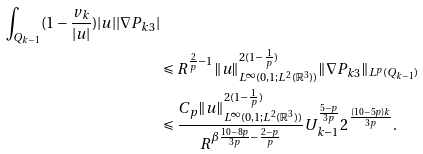Convert formula to latex. <formula><loc_0><loc_0><loc_500><loc_500>\int _ { Q _ { k - 1 } } ( 1 - \frac { v _ { k } } { | u | } ) | u | | \nabla P _ { k 3 } | \\ & \leqslant R ^ { \frac { 2 } { p } - 1 } \| u \| _ { L ^ { \infty } ( 0 , 1 ; L ^ { 2 } ( \mathbb { R } ^ { 3 } ) ) } ^ { 2 ( 1 - \frac { 1 } { p } ) } \| \nabla P _ { k 3 } \| _ { L ^ { p } ( Q _ { k - 1 } ) } \\ & \leqslant \frac { C _ { p } \| u \| _ { L ^ { \infty } ( 0 , 1 ; L ^ { 2 } ( \mathbb { R } ^ { 3 } ) ) } ^ { 2 ( 1 - \frac { 1 } { p } ) } } { R ^ { \beta \frac { 1 0 - 8 p } { 3 p } - \frac { 2 - p } { p } } } U _ { k - 1 } ^ { \frac { 5 - p } { 3 p } } 2 ^ { \frac { ( 1 0 - 5 p ) k } { 3 p } } .</formula> 